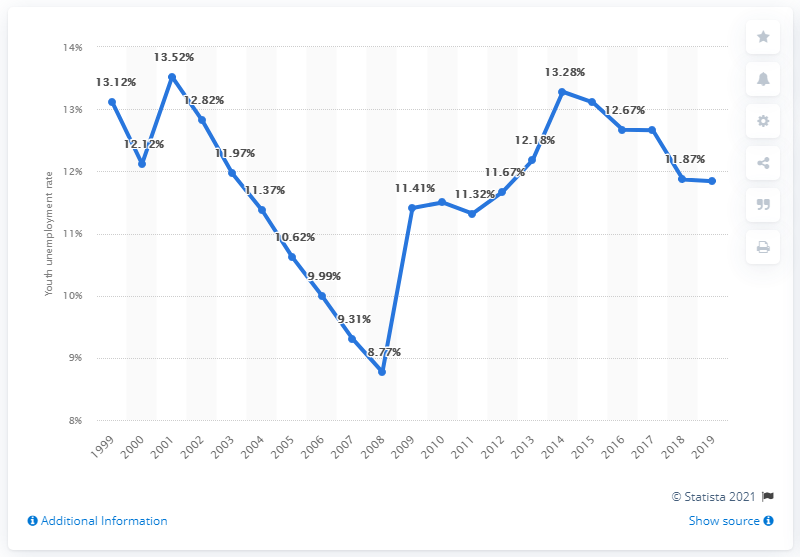Indicate a few pertinent items in this graphic. The youth unemployment rate in Australia in 2019 was 11.84%. 